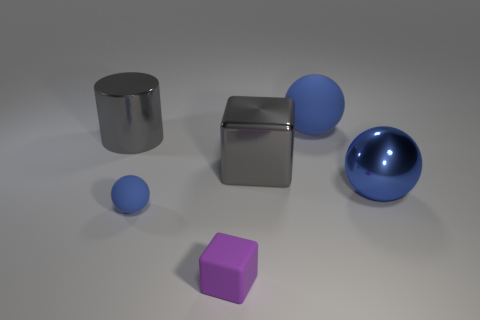How many blue spheres must be subtracted to get 1 blue spheres? 2 Add 2 tiny yellow metallic blocks. How many objects exist? 8 Subtract all rubber spheres. How many spheres are left? 1 Subtract 0 cyan cylinders. How many objects are left? 6 Subtract all cylinders. How many objects are left? 5 Subtract 2 cubes. How many cubes are left? 0 Subtract all gray blocks. Subtract all blue cylinders. How many blocks are left? 1 Subtract all blue blocks. How many cyan balls are left? 0 Subtract all large gray cylinders. Subtract all tiny shiny cylinders. How many objects are left? 5 Add 1 matte balls. How many matte balls are left? 3 